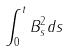Convert formula to latex. <formula><loc_0><loc_0><loc_500><loc_500>\int _ { 0 } ^ { t } B _ { s } ^ { 2 } d s</formula> 